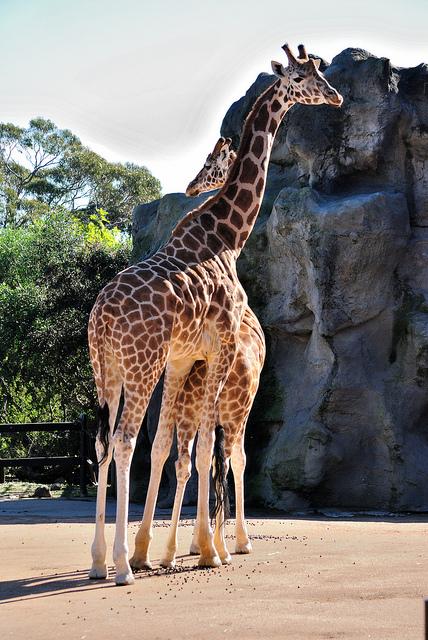Will these giraffes mate?
Answer briefly. Yes. What is this animal?
Give a very brief answer. Giraffe. How many giraffes are in the photograph?
Be succinct. 2. 